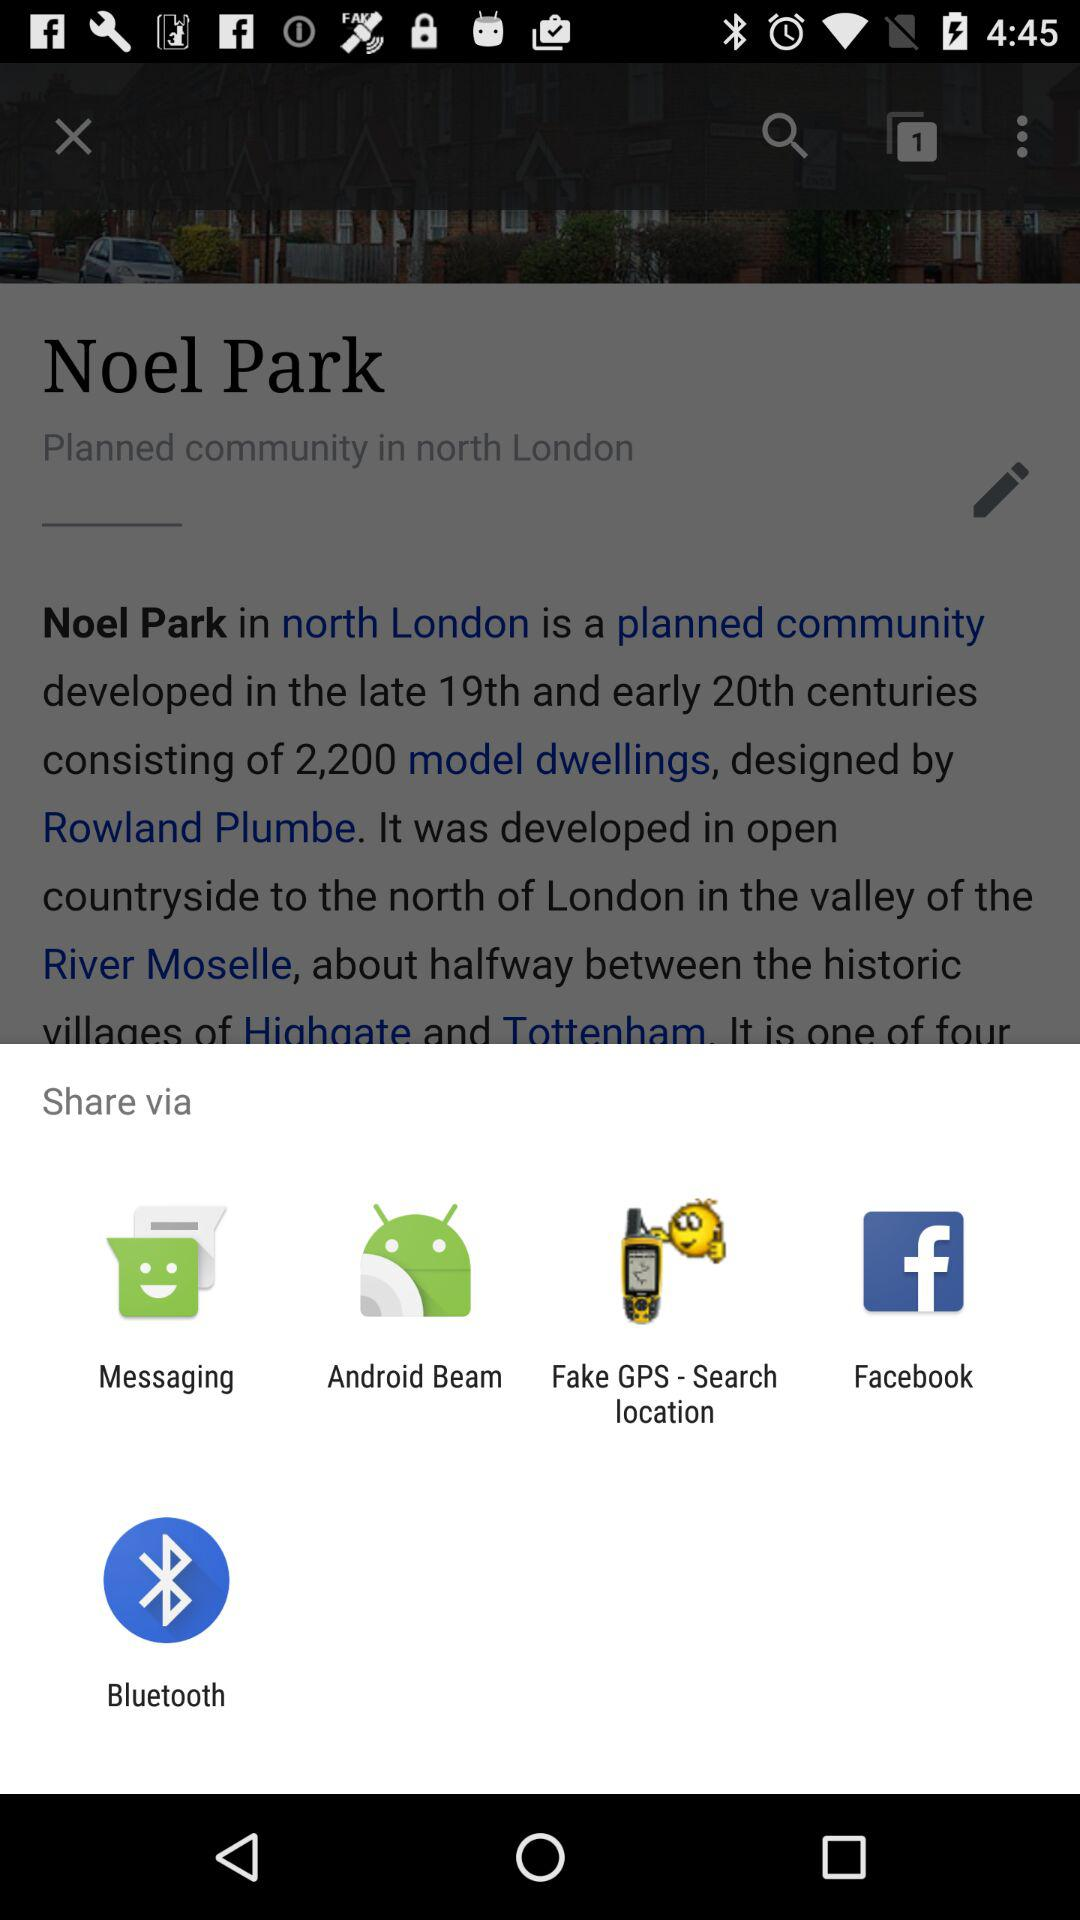What are the options available to share the information? The available options are: "Messaging", "Android Beam", "Fake GPS-Search location", "Facebook", and "Bluetooth". 